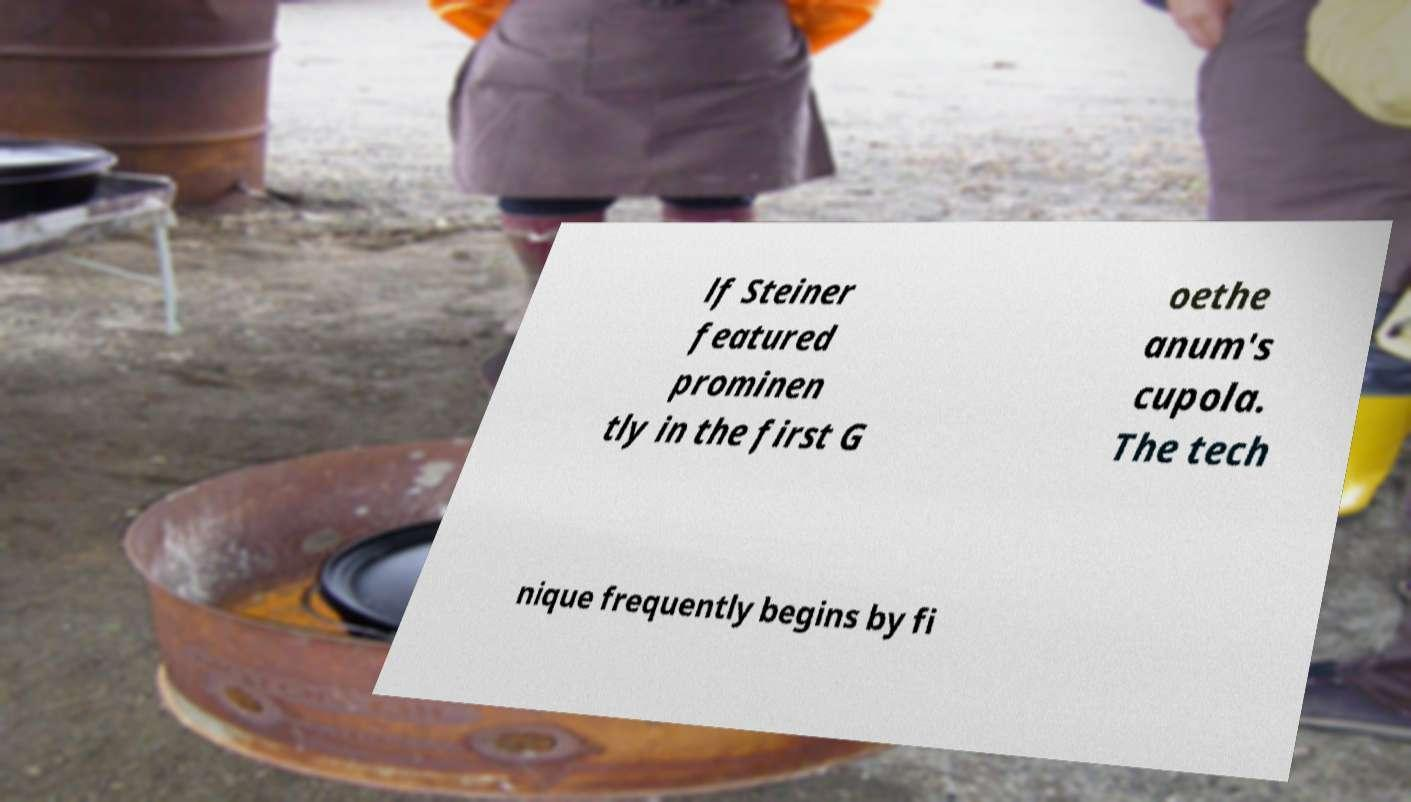Can you accurately transcribe the text from the provided image for me? lf Steiner featured prominen tly in the first G oethe anum's cupola. The tech nique frequently begins by fi 